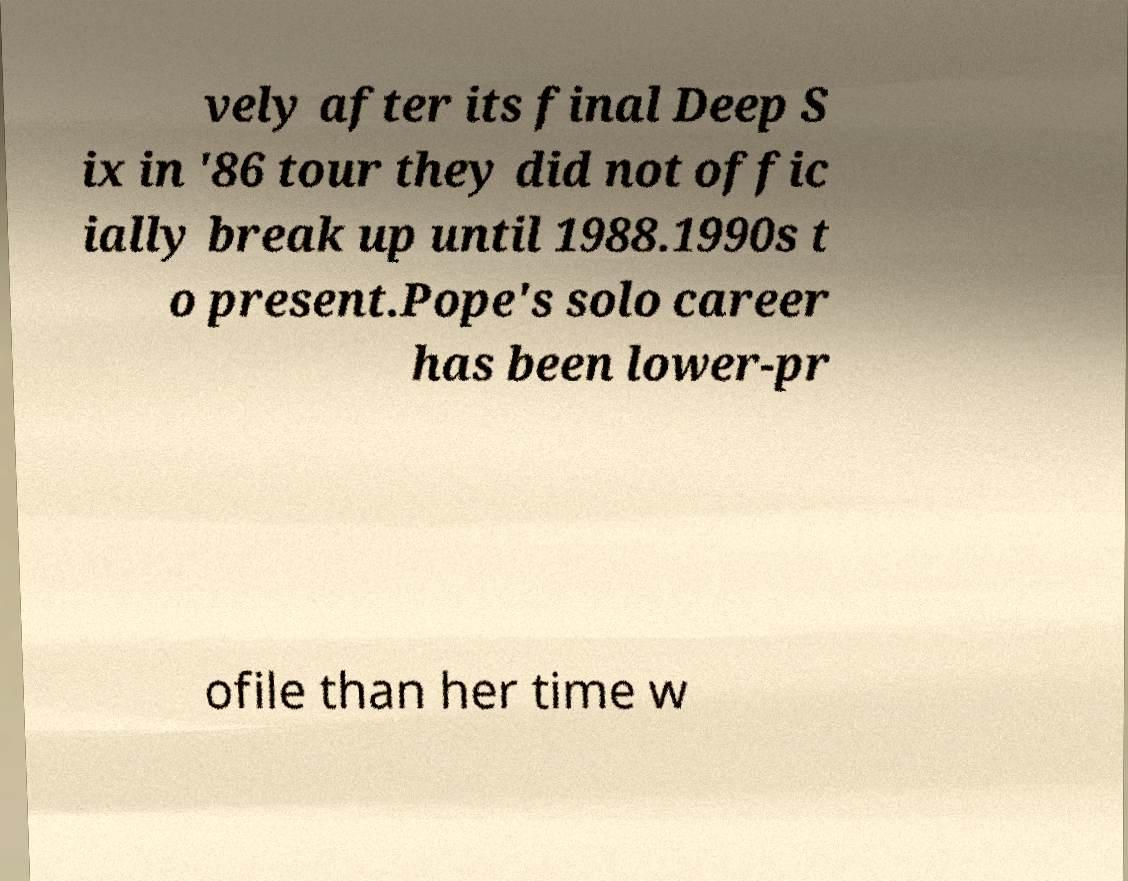Can you read and provide the text displayed in the image?This photo seems to have some interesting text. Can you extract and type it out for me? vely after its final Deep S ix in '86 tour they did not offic ially break up until 1988.1990s t o present.Pope's solo career has been lower-pr ofile than her time w 